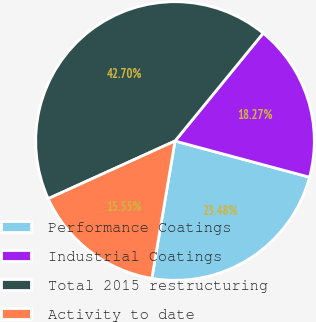<chart> <loc_0><loc_0><loc_500><loc_500><pie_chart><fcel>Performance Coatings<fcel>Industrial Coatings<fcel>Total 2015 restructuring<fcel>Activity to date<nl><fcel>23.48%<fcel>18.27%<fcel>42.7%<fcel>15.55%<nl></chart> 